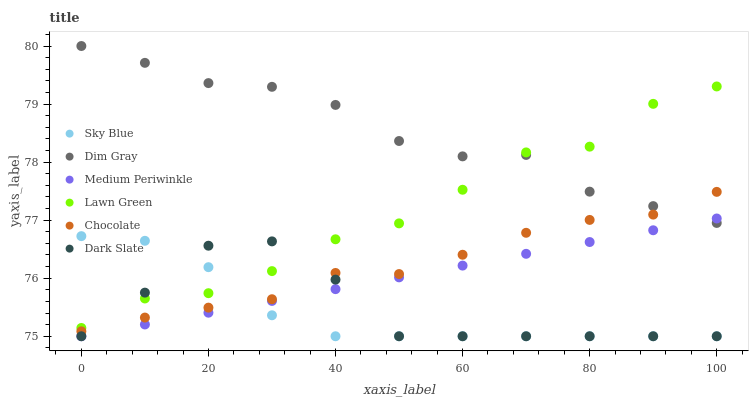Does Sky Blue have the minimum area under the curve?
Answer yes or no. Yes. Does Dim Gray have the maximum area under the curve?
Answer yes or no. Yes. Does Medium Periwinkle have the minimum area under the curve?
Answer yes or no. No. Does Medium Periwinkle have the maximum area under the curve?
Answer yes or no. No. Is Medium Periwinkle the smoothest?
Answer yes or no. Yes. Is Lawn Green the roughest?
Answer yes or no. Yes. Is Dim Gray the smoothest?
Answer yes or no. No. Is Dim Gray the roughest?
Answer yes or no. No. Does Medium Periwinkle have the lowest value?
Answer yes or no. Yes. Does Dim Gray have the lowest value?
Answer yes or no. No. Does Dim Gray have the highest value?
Answer yes or no. Yes. Does Medium Periwinkle have the highest value?
Answer yes or no. No. Is Medium Periwinkle less than Chocolate?
Answer yes or no. Yes. Is Chocolate greater than Medium Periwinkle?
Answer yes or no. Yes. Does Dark Slate intersect Chocolate?
Answer yes or no. Yes. Is Dark Slate less than Chocolate?
Answer yes or no. No. Is Dark Slate greater than Chocolate?
Answer yes or no. No. Does Medium Periwinkle intersect Chocolate?
Answer yes or no. No. 